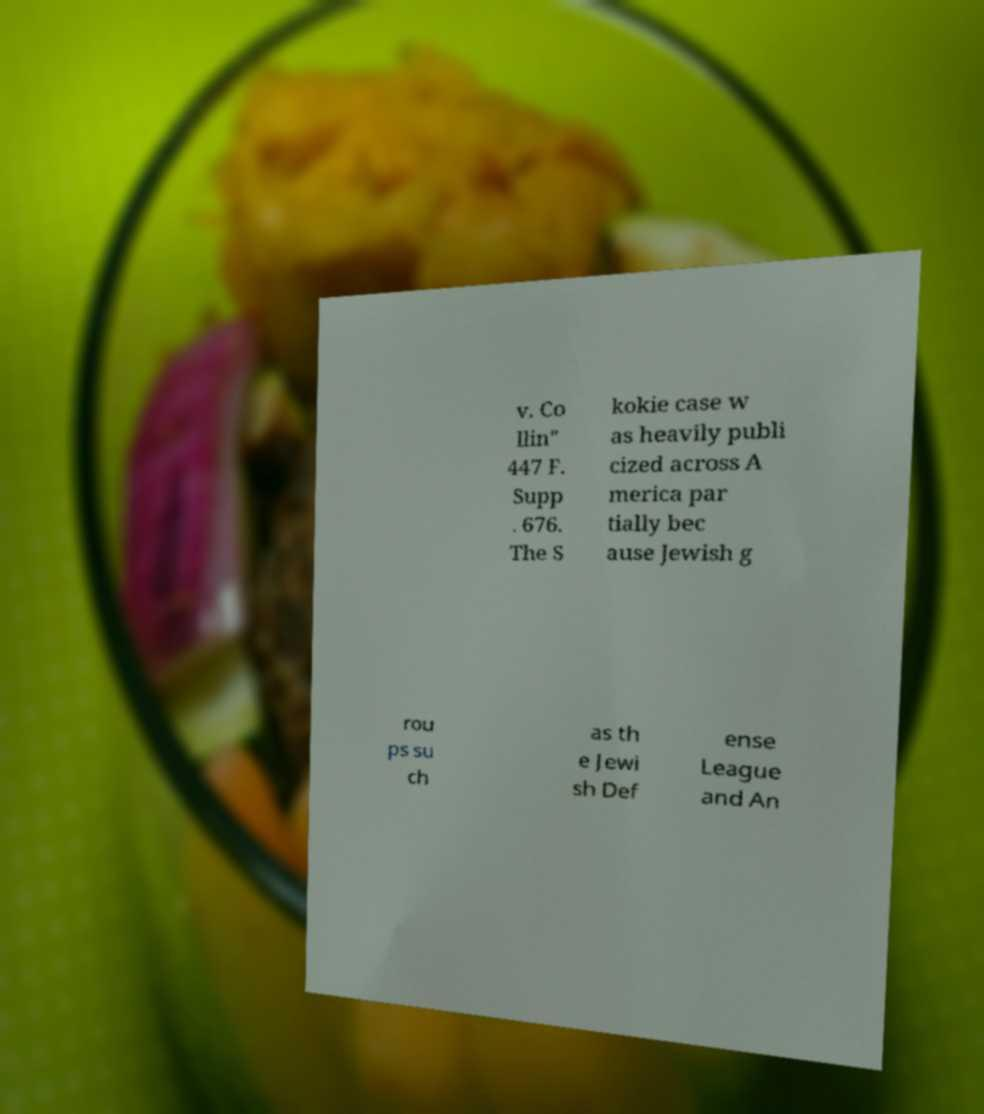For documentation purposes, I need the text within this image transcribed. Could you provide that? v. Co llin" 447 F. Supp . 676. The S kokie case w as heavily publi cized across A merica par tially bec ause Jewish g rou ps su ch as th e Jewi sh Def ense League and An 